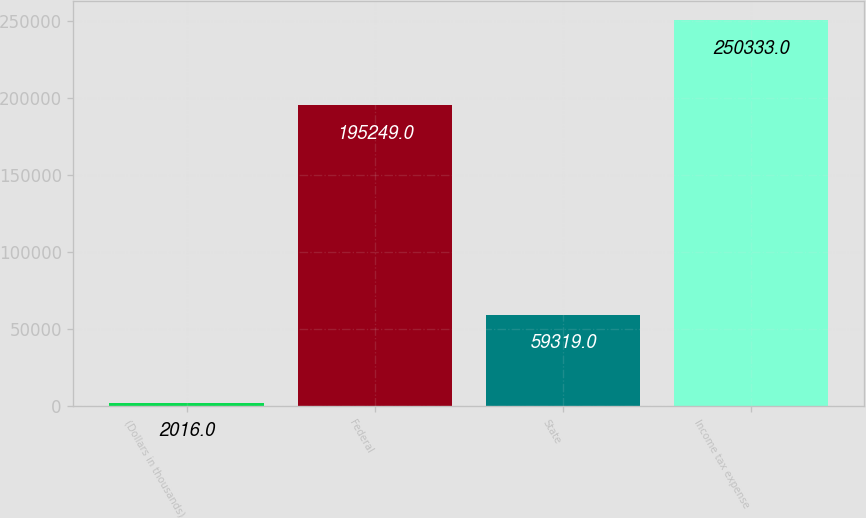Convert chart. <chart><loc_0><loc_0><loc_500><loc_500><bar_chart><fcel>(Dollars in thousands)<fcel>Federal<fcel>State<fcel>Income tax expense<nl><fcel>2016<fcel>195249<fcel>59319<fcel>250333<nl></chart> 